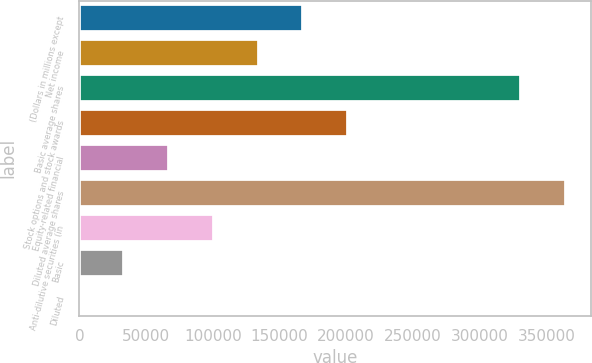<chart> <loc_0><loc_0><loc_500><loc_500><bar_chart><fcel>(Dollars in millions except<fcel>Net income<fcel>Basic average shares<fcel>Stock options and stock awards<fcel>Equity-related financial<fcel>Diluted average shares<fcel>Anti-dilutive securities (in<fcel>Basic<fcel>Diluted<nl><fcel>167868<fcel>134295<fcel>331350<fcel>201441<fcel>67149<fcel>364923<fcel>100722<fcel>33576.2<fcel>3.29<nl></chart> 